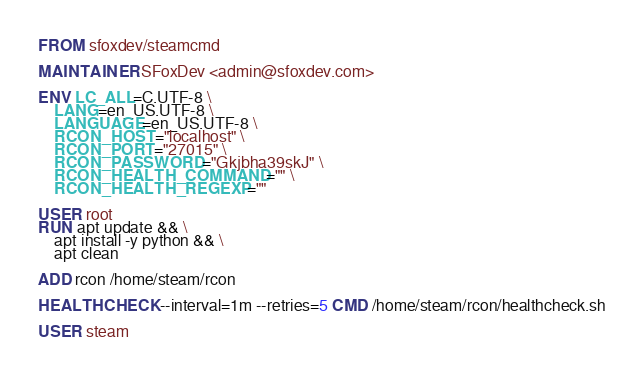Convert code to text. <code><loc_0><loc_0><loc_500><loc_500><_Dockerfile_>FROM sfoxdev/steamcmd

MAINTAINER SFoxDev <admin@sfoxdev.com>

ENV LC_ALL=C.UTF-8 \
	LANG=en_US.UTF-8 \
	LANGUAGE=en_US.UTF-8 \
	RCON_HOST="localhost" \
	RCON_PORT="27015" \
	RCON_PASSWORD="Gkjbha39skJ" \
	RCON_HEALTH_COMMAND="" \
	RCON_HEALTH_REGEXP=""

USER root
RUN apt update && \
	apt install -y python && \
	apt clean

ADD rcon /home/steam/rcon

HEALTHCHECK --interval=1m --retries=5 CMD /home/steam/rcon/healthcheck.sh

USER steam
</code> 